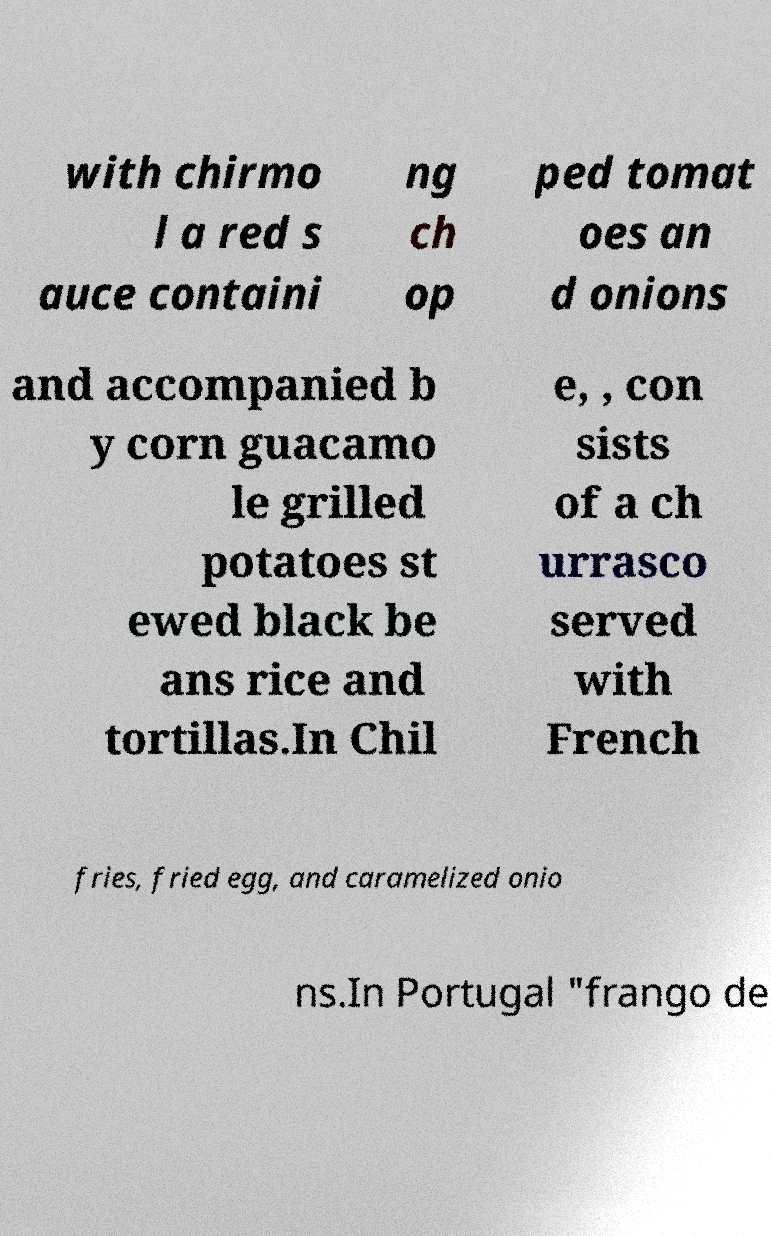I need the written content from this picture converted into text. Can you do that? with chirmo l a red s auce containi ng ch op ped tomat oes an d onions and accompanied b y corn guacamo le grilled potatoes st ewed black be ans rice and tortillas.In Chil e, , con sists of a ch urrasco served with French fries, fried egg, and caramelized onio ns.In Portugal "frango de 